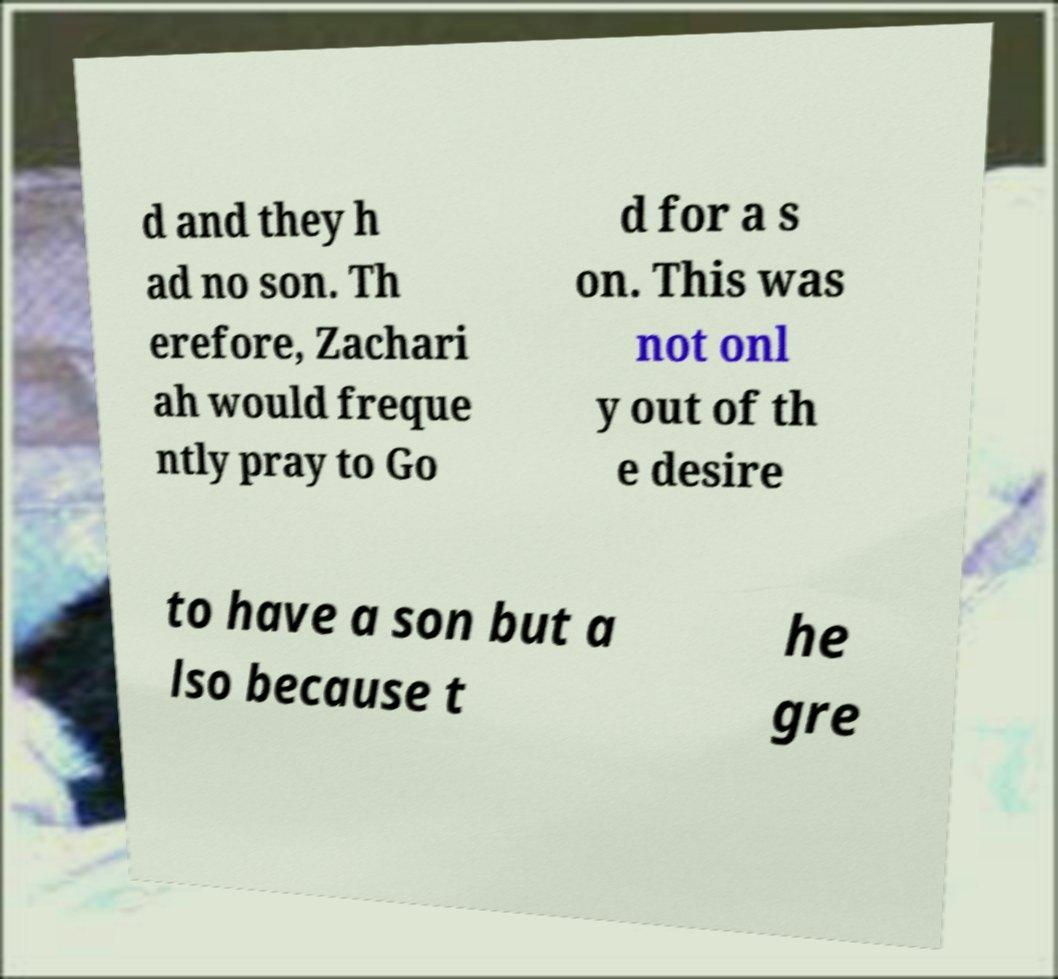Please read and relay the text visible in this image. What does it say? d and they h ad no son. Th erefore, Zachari ah would freque ntly pray to Go d for a s on. This was not onl y out of th e desire to have a son but a lso because t he gre 